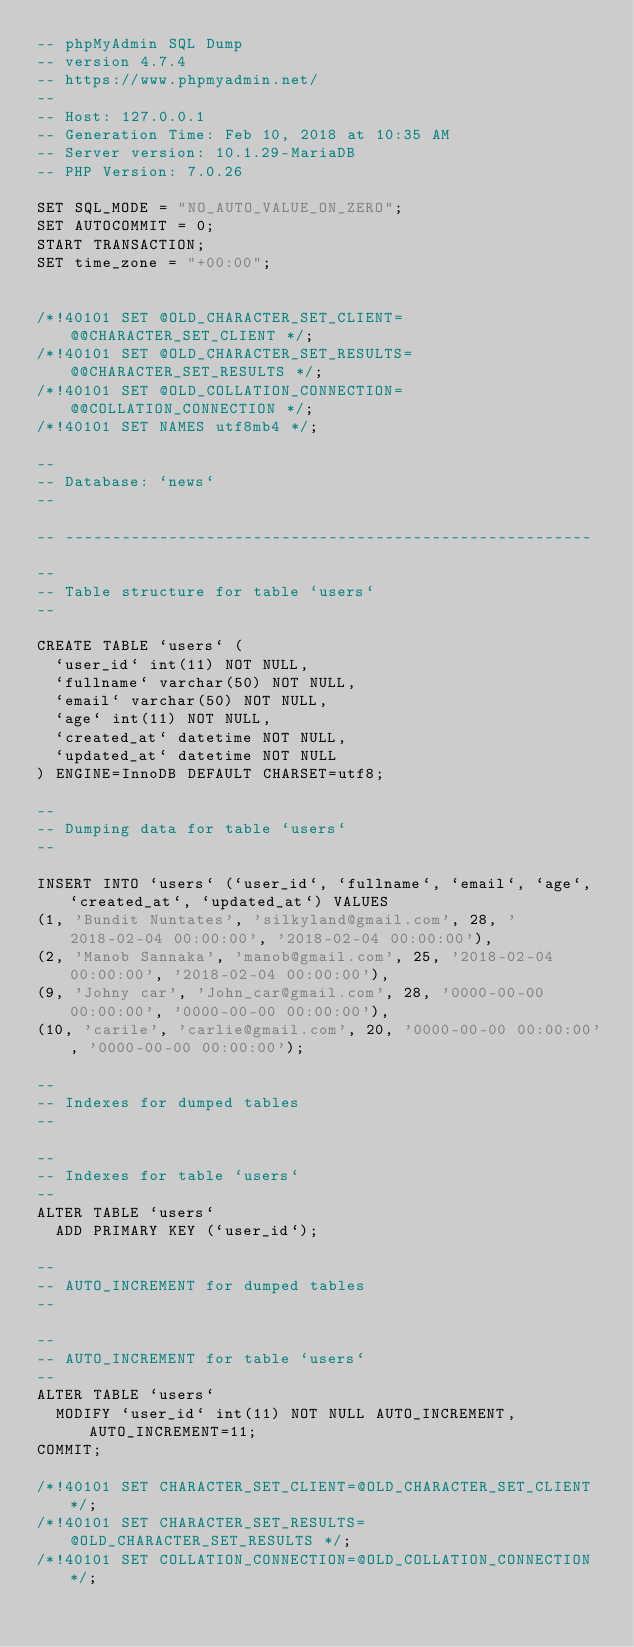Convert code to text. <code><loc_0><loc_0><loc_500><loc_500><_SQL_>-- phpMyAdmin SQL Dump
-- version 4.7.4
-- https://www.phpmyadmin.net/
--
-- Host: 127.0.0.1
-- Generation Time: Feb 10, 2018 at 10:35 AM
-- Server version: 10.1.29-MariaDB
-- PHP Version: 7.0.26

SET SQL_MODE = "NO_AUTO_VALUE_ON_ZERO";
SET AUTOCOMMIT = 0;
START TRANSACTION;
SET time_zone = "+00:00";


/*!40101 SET @OLD_CHARACTER_SET_CLIENT=@@CHARACTER_SET_CLIENT */;
/*!40101 SET @OLD_CHARACTER_SET_RESULTS=@@CHARACTER_SET_RESULTS */;
/*!40101 SET @OLD_COLLATION_CONNECTION=@@COLLATION_CONNECTION */;
/*!40101 SET NAMES utf8mb4 */;

--
-- Database: `news`
--

-- --------------------------------------------------------

--
-- Table structure for table `users`
--

CREATE TABLE `users` (
  `user_id` int(11) NOT NULL,
  `fullname` varchar(50) NOT NULL,
  `email` varchar(50) NOT NULL,
  `age` int(11) NOT NULL,
  `created_at` datetime NOT NULL,
  `updated_at` datetime NOT NULL
) ENGINE=InnoDB DEFAULT CHARSET=utf8;

--
-- Dumping data for table `users`
--

INSERT INTO `users` (`user_id`, `fullname`, `email`, `age`, `created_at`, `updated_at`) VALUES
(1, 'Bundit Nuntates', 'silkyland@gmail.com', 28, '2018-02-04 00:00:00', '2018-02-04 00:00:00'),
(2, 'Manob Sannaka', 'manob@gmail.com', 25, '2018-02-04 00:00:00', '2018-02-04 00:00:00'),
(9, 'Johny car', 'John_car@gmail.com', 28, '0000-00-00 00:00:00', '0000-00-00 00:00:00'),
(10, 'carile', 'carlie@gmail.com', 20, '0000-00-00 00:00:00', '0000-00-00 00:00:00');

--
-- Indexes for dumped tables
--

--
-- Indexes for table `users`
--
ALTER TABLE `users`
  ADD PRIMARY KEY (`user_id`);

--
-- AUTO_INCREMENT for dumped tables
--

--
-- AUTO_INCREMENT for table `users`
--
ALTER TABLE `users`
  MODIFY `user_id` int(11) NOT NULL AUTO_INCREMENT, AUTO_INCREMENT=11;
COMMIT;

/*!40101 SET CHARACTER_SET_CLIENT=@OLD_CHARACTER_SET_CLIENT */;
/*!40101 SET CHARACTER_SET_RESULTS=@OLD_CHARACTER_SET_RESULTS */;
/*!40101 SET COLLATION_CONNECTION=@OLD_COLLATION_CONNECTION */;
</code> 